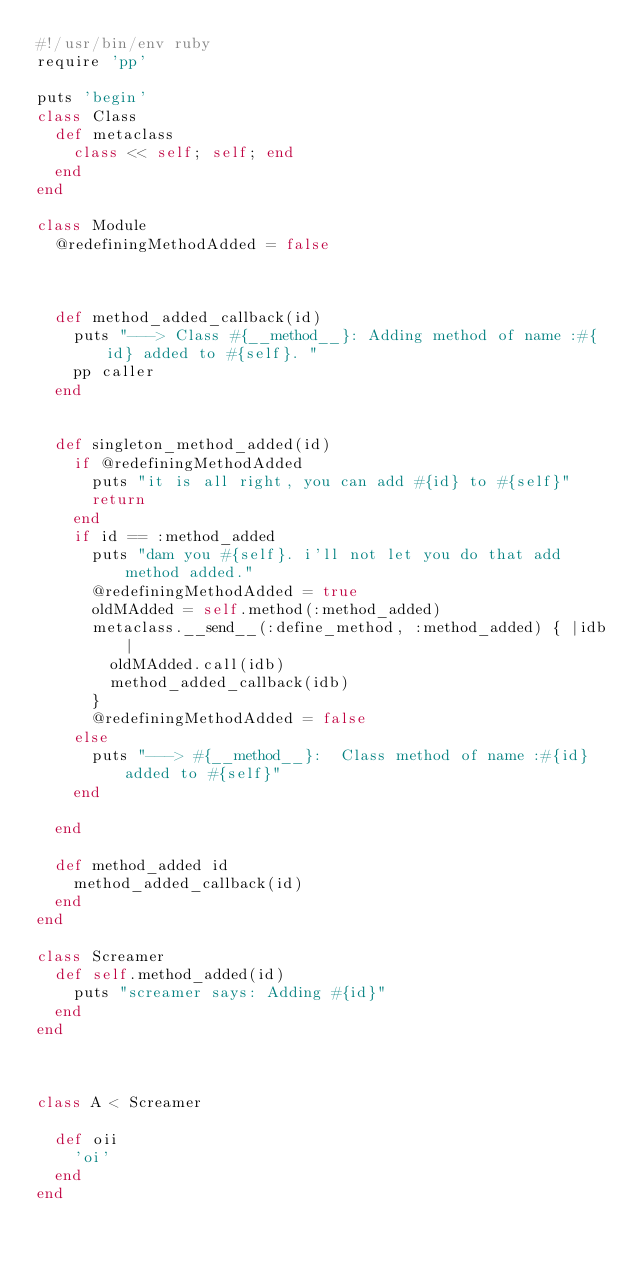Convert code to text. <code><loc_0><loc_0><loc_500><loc_500><_Ruby_>#!/usr/bin/env ruby
require 'pp'

puts 'begin'
class Class
  def metaclass
    class << self; self; end
  end
end

class Module
  @redefiningMethodAdded = false

  

  def method_added_callback(id)
    puts "---> Class #{__method__}: Adding method of name :#{id} added to #{self}. "
    pp caller
  end


  def singleton_method_added(id)
    if @redefiningMethodAdded
      puts "it is all right, you can add #{id} to #{self}"
      return
    end
    if id == :method_added
      puts "dam you #{self}. i'll not let you do that add method added."
      @redefiningMethodAdded = true
      oldMAdded = self.method(:method_added)
      metaclass.__send__(:define_method, :method_added) { |idb|
        oldMAdded.call(idb)
        method_added_callback(idb)
      }
      @redefiningMethodAdded = false
    else
      puts "---> #{__method__}:  Class method of name :#{id} added to #{self}"
    end
    
  end

  def method_added id
    method_added_callback(id)
  end
end

class Screamer
  def self.method_added(id)
    puts "screamer says: Adding #{id}"
  end
end



class A < Screamer

  def oii
    'oi'
  end
end
</code> 